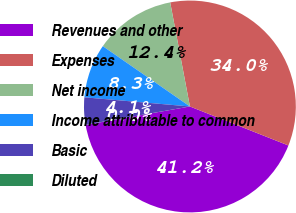Convert chart to OTSL. <chart><loc_0><loc_0><loc_500><loc_500><pie_chart><fcel>Revenues and other<fcel>Expenses<fcel>Net income<fcel>Income attributable to common<fcel>Basic<fcel>Diluted<nl><fcel>41.22%<fcel>33.98%<fcel>12.38%<fcel>8.26%<fcel>4.14%<fcel>0.02%<nl></chart> 